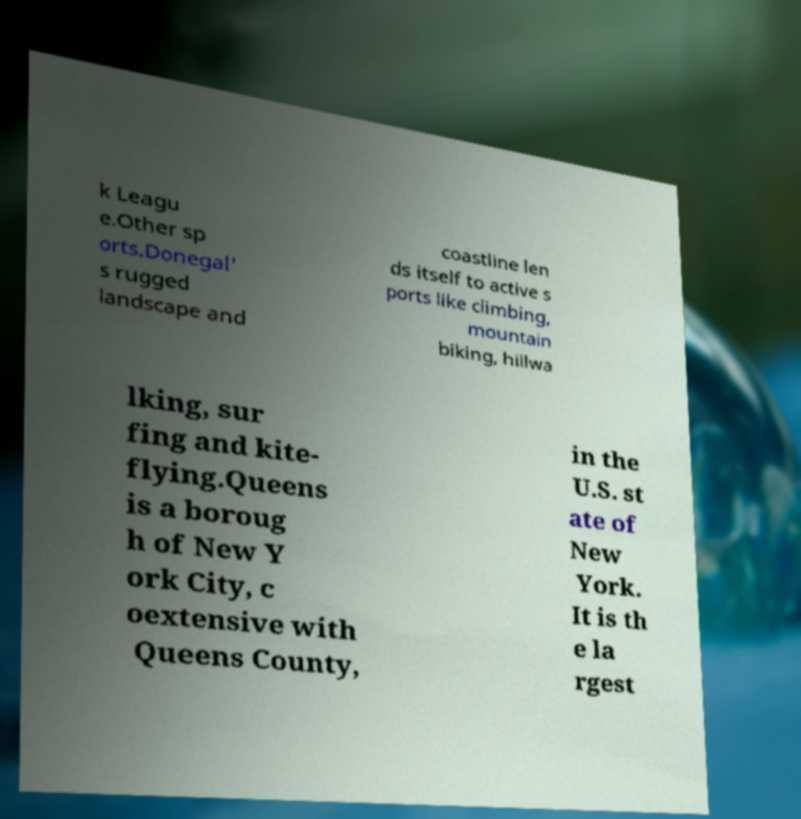I need the written content from this picture converted into text. Can you do that? Certainly! The text from the image reads: 'k League. Other sports. Donegal's rugged landscape and coastline lends itself to active sports like climbing, mountain biking, hillwalking, surfing and kite-flying. Queens is a borough of New York City, coextensive with Queens County, in the U.S. state of New York. It is the largest' 